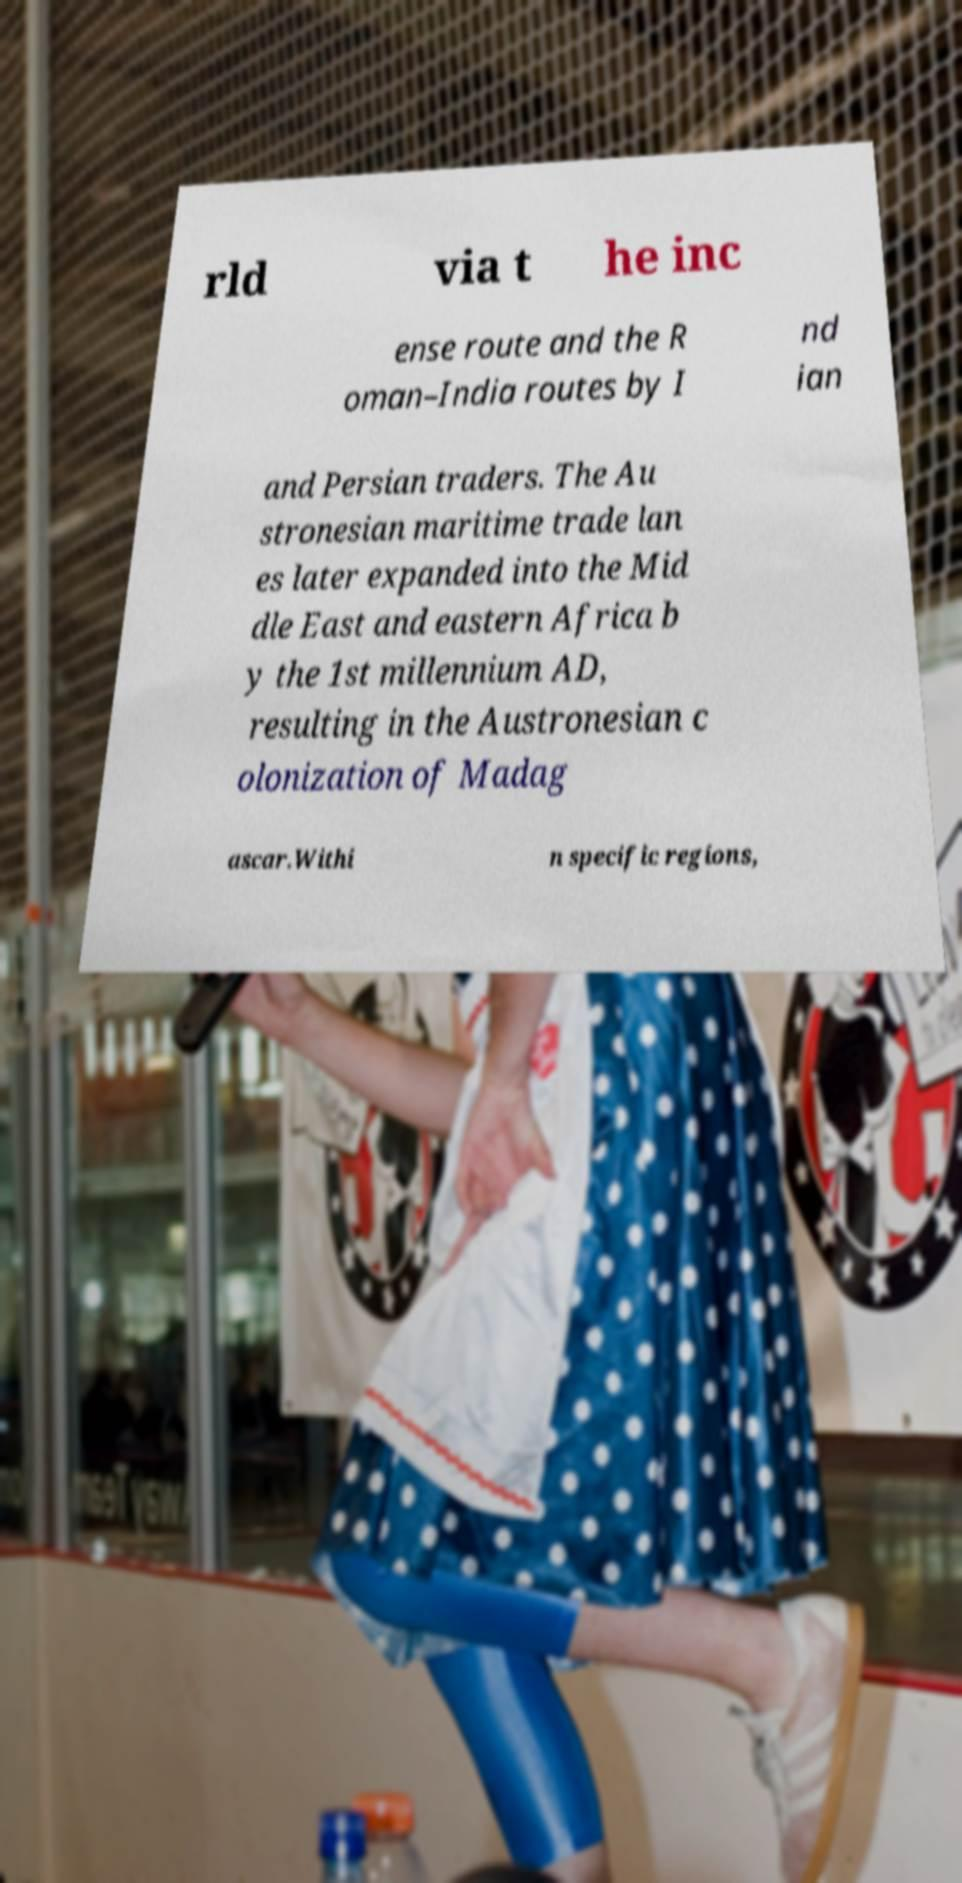Can you read and provide the text displayed in the image?This photo seems to have some interesting text. Can you extract and type it out for me? rld via t he inc ense route and the R oman–India routes by I nd ian and Persian traders. The Au stronesian maritime trade lan es later expanded into the Mid dle East and eastern Africa b y the 1st millennium AD, resulting in the Austronesian c olonization of Madag ascar.Withi n specific regions, 